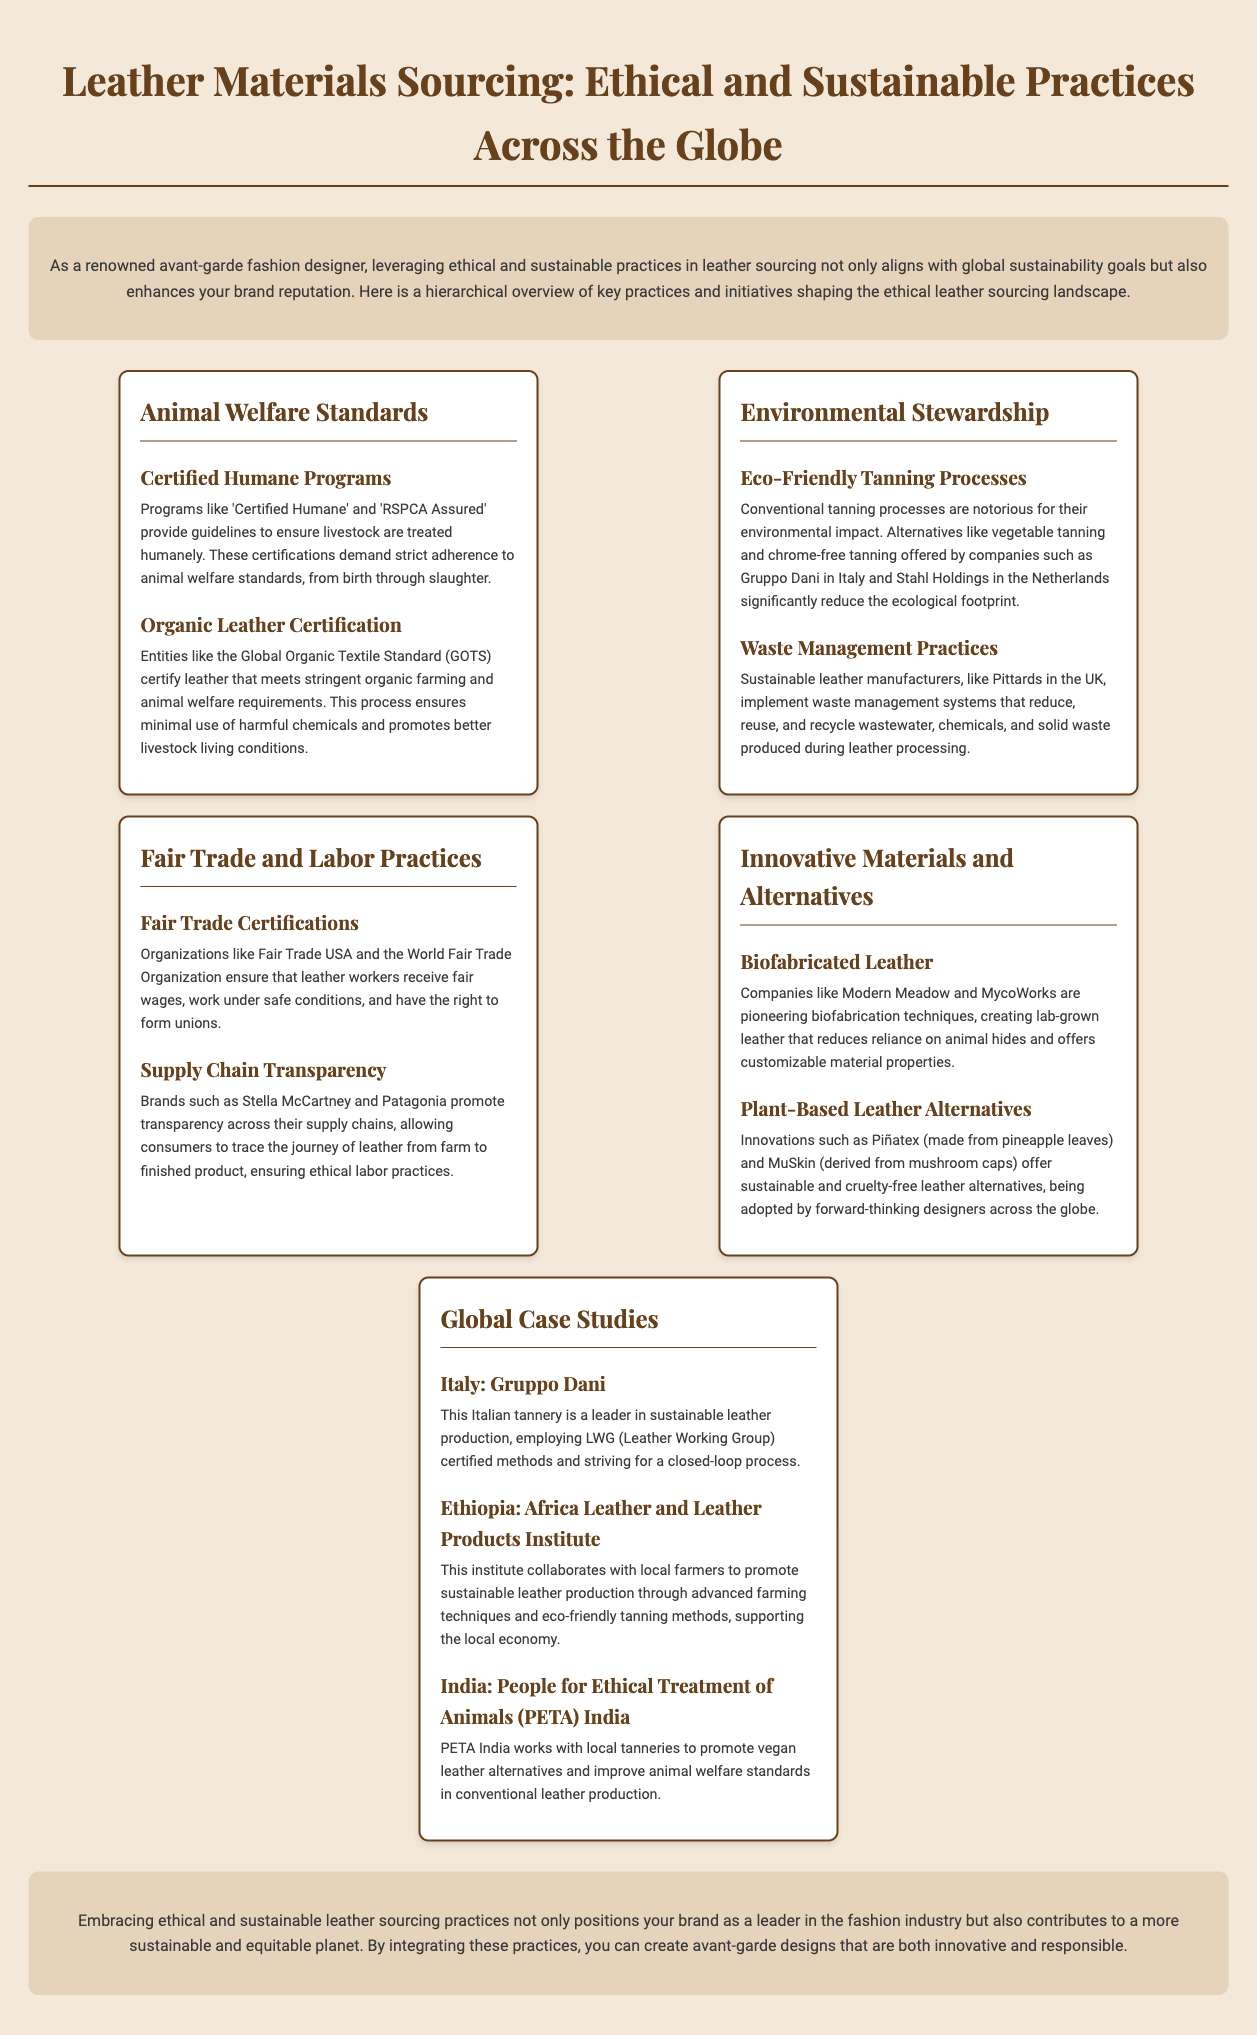what are the names of two humane certification programs? The document lists 'Certified Humane' and 'RSPCA Assured' as humane certification programs.
Answer: Certified Humane, RSPCA Assured what is the name of the standard that certifies organic leather? The Global Organic Textile Standard (GOTS) is mentioned as the certifying body for organic leather.
Answer: Global Organic Textile Standard (GOTS) which eco-friendly tanning method significantly reduces ecological impact? The document highlights vegetable tanning and chrome-free tanning as eco-friendly methods.
Answer: Vegetable tanning, chrome-free tanning name one sustainable leather manufacturer from the UK. Pittards is cited as a sustainable leather manufacturer based in the UK.
Answer: Pittards who are two companies pioneering biofabricated leather? Modern Meadow and MycoWorks are named as companies working on biofabricated leather.
Answer: Modern Meadow, MycoWorks what is the primary focus of Fair Trade certifications? Fair Trade certifications focus on ensuring that leather workers receive fair wages and work under safe conditions.
Answer: Fair wages, safe conditions which country is home to the Gruppo Dani tannery? Gruppo Dani is located in Italy, as stated in the document.
Answer: Italy what innovation is Piñatex made from? According to the document, Piñatex is made from pineapple leaves.
Answer: Pineapple leaves how many global case studies are presented in the infographic? The infographic presents three global case studies.
Answer: Three 